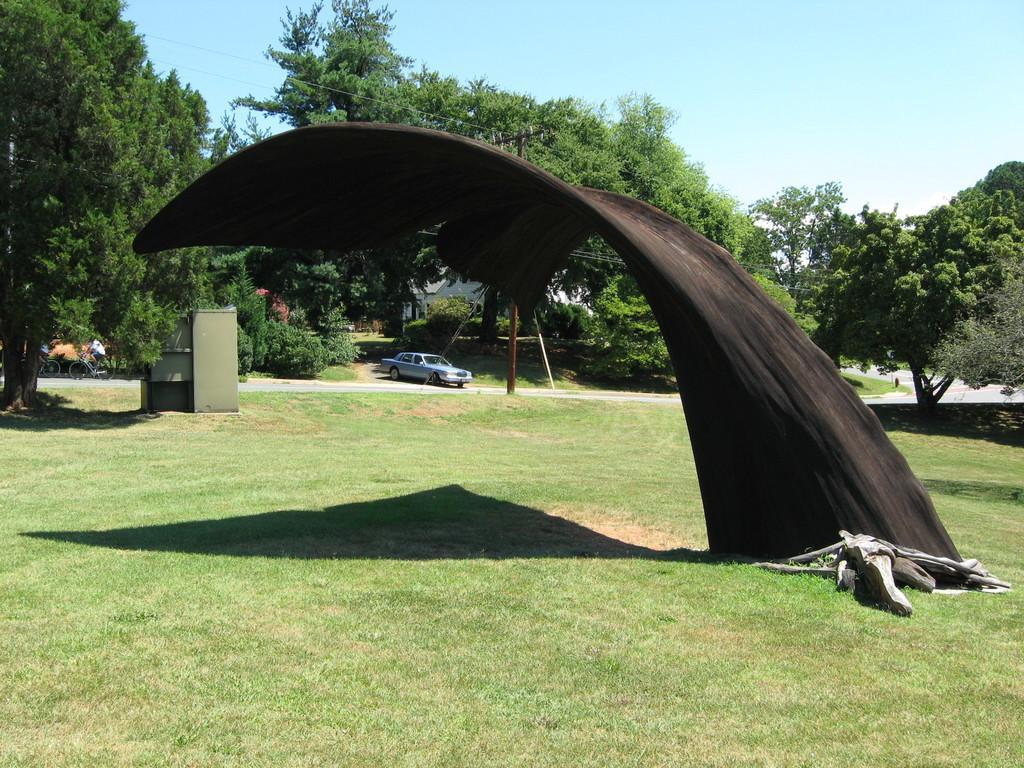In one or two sentences, can you explain what this image depicts? In this picture we can see an architecture, grass and trees. There is a person riding bicycle on the road, car, pole, wires and objects. In the background of the image we can see the sky. 